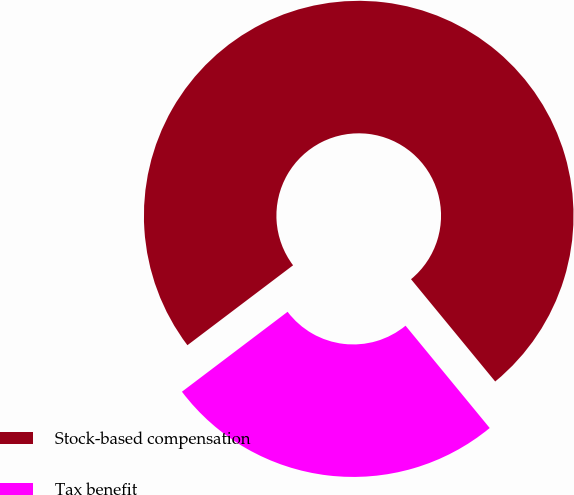Convert chart to OTSL. <chart><loc_0><loc_0><loc_500><loc_500><pie_chart><fcel>Stock-based compensation<fcel>Tax benefit<nl><fcel>74.35%<fcel>25.65%<nl></chart> 